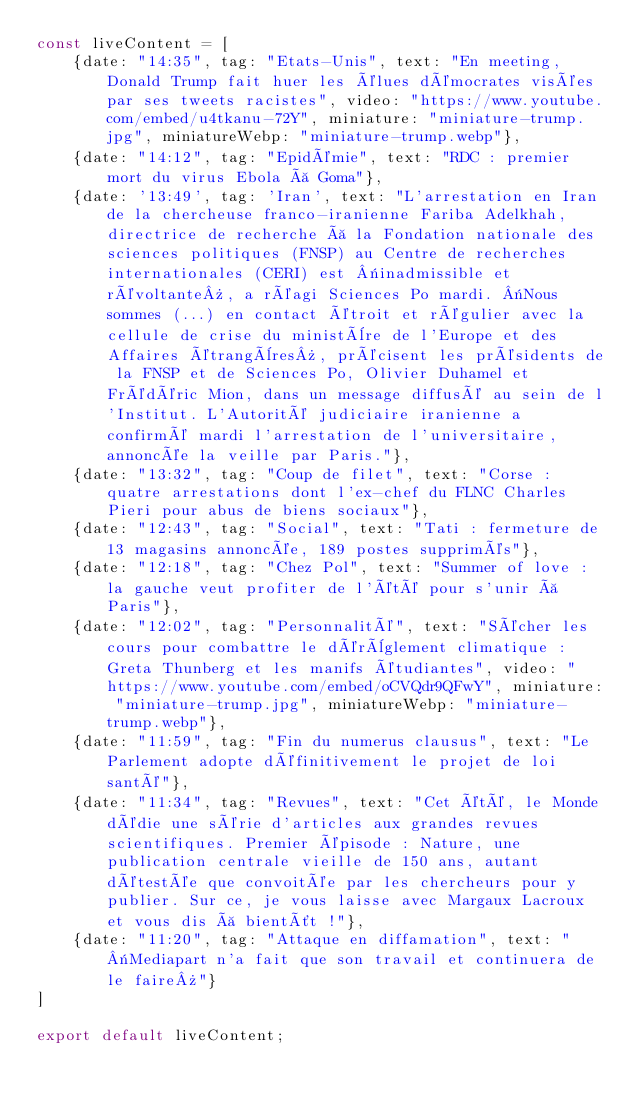<code> <loc_0><loc_0><loc_500><loc_500><_JavaScript_>const liveContent = [
    {date: "14:35", tag: "Etats-Unis", text: "En meeting, Donald Trump fait huer les élues démocrates visées par ses tweets racistes", video: "https://www.youtube.com/embed/u4tkanu-72Y", miniature: "miniature-trump.jpg", miniatureWebp: "miniature-trump.webp"},
    {date: "14:12", tag: "Epidémie", text: "RDC : premier mort du virus Ebola à Goma"},
    {date: '13:49', tag: 'Iran', text: "L'arrestation en Iran de la chercheuse franco-iranienne Fariba Adelkhah, directrice de recherche à la Fondation nationale des sciences politiques (FNSP) au Centre de recherches internationales (CERI) est «inadmissible et révoltante», a réagi Sciences Po mardi. «Nous sommes (...) en contact étroit et régulier avec la cellule de crise du ministère de l'Europe et des Affaires étrangères», précisent les présidents de la FNSP et de Sciences Po, Olivier Duhamel et Frédéric Mion, dans un message diffusé au sein de l'Institut. L'Autorité judiciaire iranienne a confirmé mardi l'arrestation de l'universitaire, annoncée la veille par Paris."},
    {date: "13:32", tag: "Coup de filet", text: "Corse : quatre arrestations dont l'ex-chef du FLNC Charles Pieri pour abus de biens sociaux"},
    {date: "12:43", tag: "Social", text: "Tati : fermeture de 13 magasins annoncée, 189 postes supprimés"},
    {date: "12:18", tag: "Chez Pol", text: "Summer of love : la gauche veut profiter de l'été pour s'unir à Paris"},
    {date: "12:02", tag: "Personnalité", text: "Sécher les cours pour combattre le dérèglement climatique : Greta Thunberg et les manifs étudiantes", video: "https://www.youtube.com/embed/oCVQdr9QFwY", miniature: "miniature-trump.jpg", miniatureWebp: "miniature-trump.webp"},
    {date: "11:59", tag: "Fin du numerus clausus", text: "Le Parlement adopte définitivement le projet de loi santé"},
    {date: "11:34", tag: "Revues", text: "Cet été, le Monde dédie une série d'articles aux grandes revues scientifiques. Premier épisode : Nature, une publication centrale vieille de 150 ans, autant détestée que convoitée par les chercheurs pour y publier. Sur ce, je vous laisse avec Margaux Lacroux et vous dis à bientôt !"},
    {date: "11:20", tag: "Attaque en diffamation", text: "«Mediapart n'a fait que son travail et continuera de le faire»"}
]

export default liveContent;</code> 